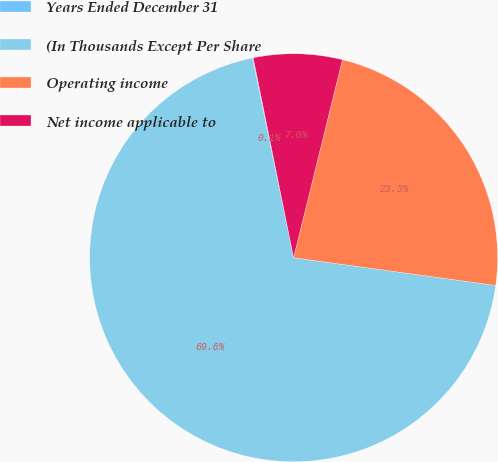Convert chart to OTSL. <chart><loc_0><loc_0><loc_500><loc_500><pie_chart><fcel>Years Ended December 31<fcel>(In Thousands Except Per Share<fcel>Operating income<fcel>Net income applicable to<nl><fcel>0.07%<fcel>69.59%<fcel>23.32%<fcel>7.02%<nl></chart> 